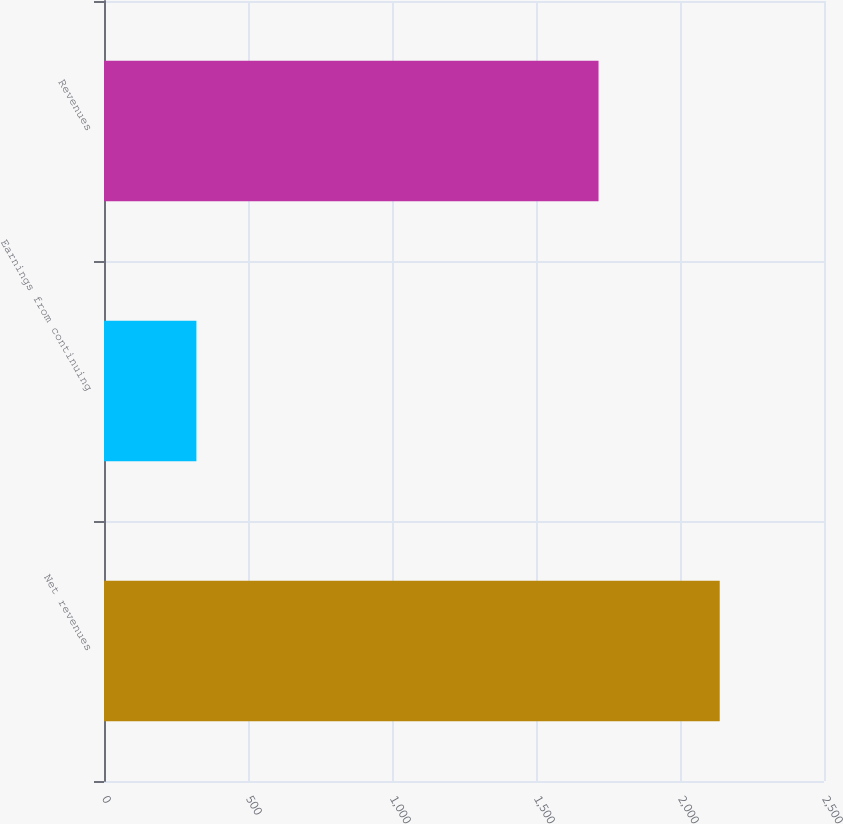Convert chart. <chart><loc_0><loc_0><loc_500><loc_500><bar_chart><fcel>Net revenues<fcel>Earnings from continuing<fcel>Revenues<nl><fcel>2137.9<fcel>320.8<fcel>1717.1<nl></chart> 